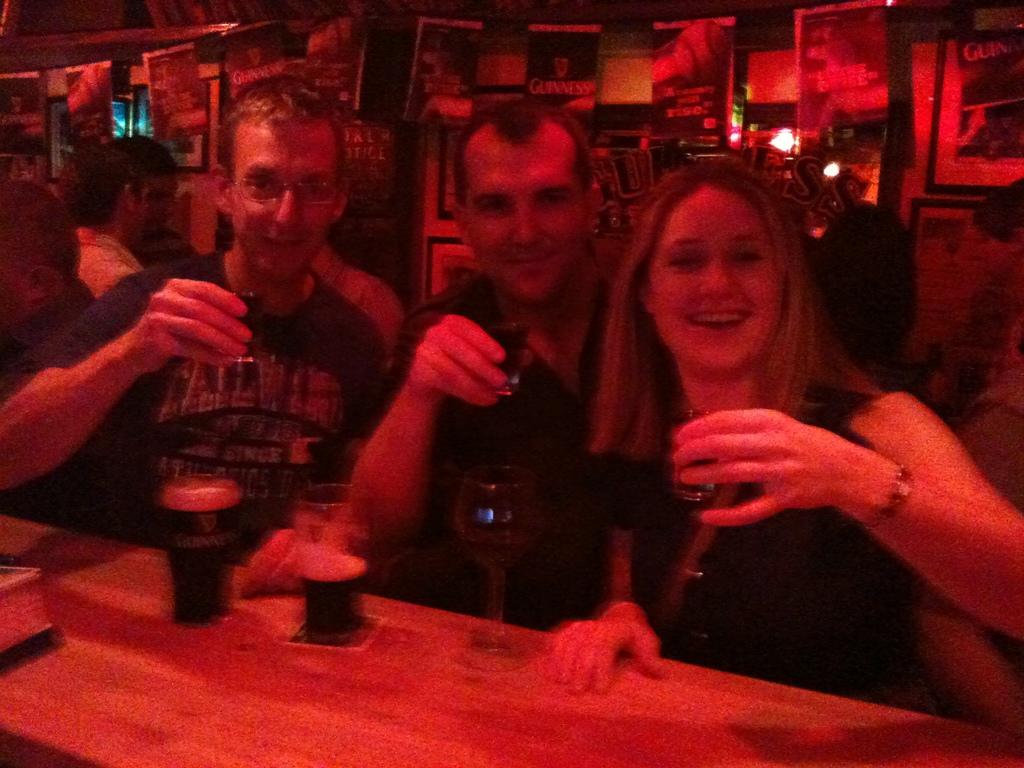How many people are in the image? There are three persons in the image. What are the persons doing in the image? The persons are having their drinks. What is present on which the persons are having their drinks? There is a table in the image. What objects can be seen on the table? There are glasses on the table. Can you tell me how many giants are present in the image? There are no giants present in the image; it features three persons. What type of motion can be seen in the image? The image does not depict any motion; it shows three people having their drinks at a table. 